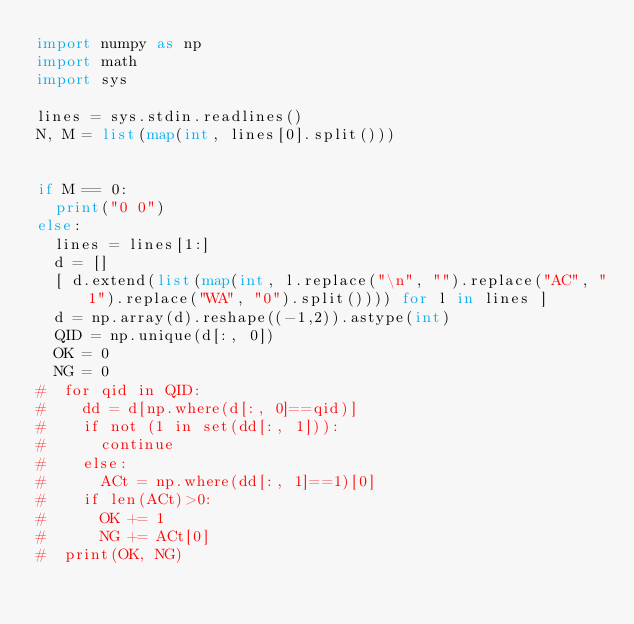Convert code to text. <code><loc_0><loc_0><loc_500><loc_500><_Python_>import numpy as np
import math
import sys
 
lines = sys.stdin.readlines()
N, M = list(map(int, lines[0].split()))
 

if M == 0:
  print("0 0")
else:
  lines = lines[1:]
  d = []
  [ d.extend(list(map(int, l.replace("\n", "").replace("AC", "1").replace("WA", "0").split()))) for l in lines ]
  d = np.array(d).reshape((-1,2)).astype(int)
  QID = np.unique(d[:, 0])
  OK = 0
  NG = 0
#  for qid in QID:
#    dd = d[np.where(d[:, 0]==qid)]
#    if not (1 in set(dd[:, 1])):
#      continue
#    else:
#      ACt = np.where(dd[:, 1]==1)[0]
#    if len(ACt)>0:
#      OK += 1
#      NG += ACt[0]
#  print(OK, NG)</code> 